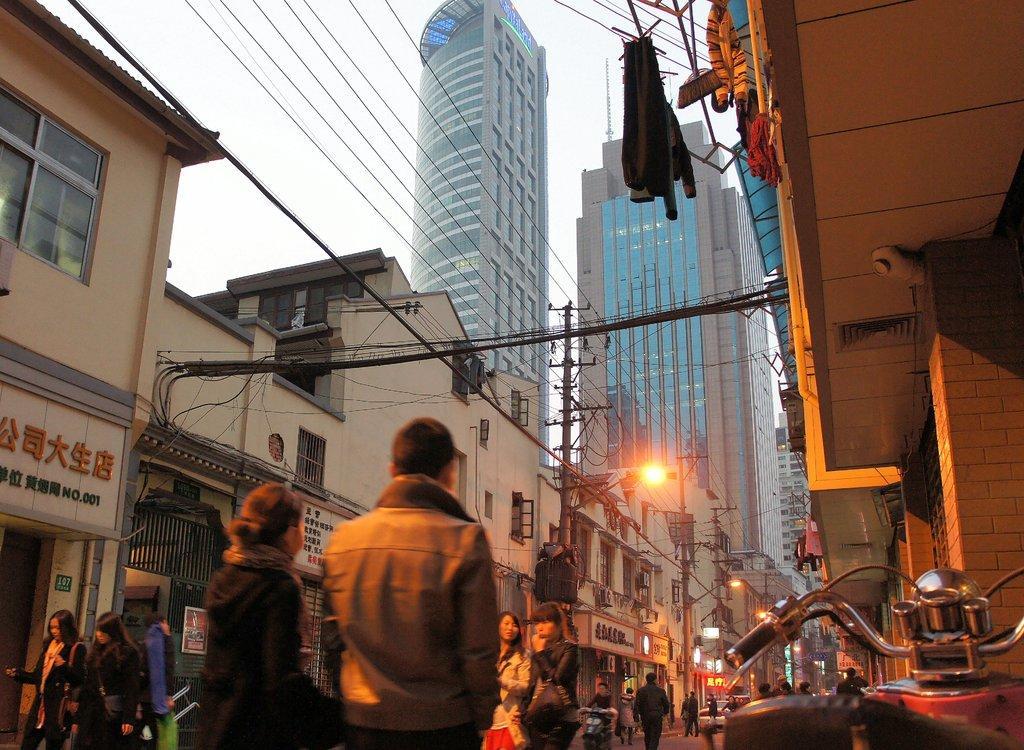Please provide a concise description of this image. In this image there are group of persons walking on the road, there are vehicles on the road, there are wires, there are poles, there is a streetlight, there are buildings, there is a sky, there are clothes hanged. 